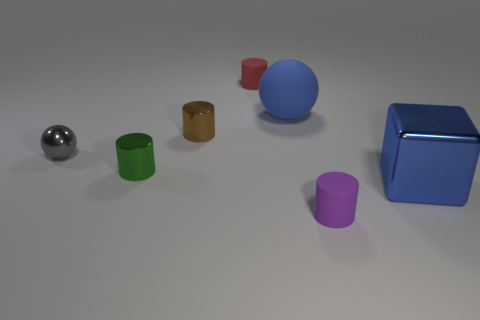Can you describe the colors and shapes of all the objects present in the image? Certainly! The image features a glossy silver sphere, a red cylinder, a green cylinder, an amber cylinder, a blue sphere, a purple cylinder, and a blue cube. Their shapes and colors create a vibrant contrast against the neutral background. 